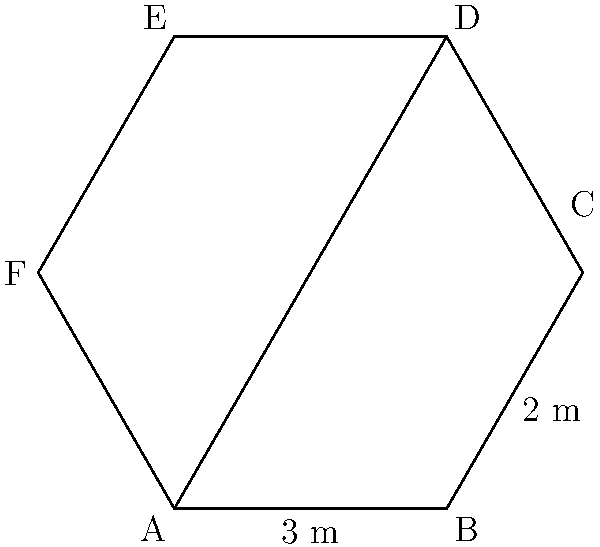A new coffee shop in your chain features a hexagonal coffee bar counter. Two sides of the hexagon measure 3 meters and 2 meters, as shown in the diagram. If all opposite sides of the hexagon are parallel and equal in length, calculate the perimeter of the coffee bar counter. To find the perimeter of the hexagonal coffee bar counter, we need to follow these steps:

1) In a hexagon with parallel opposite sides, there are three pairs of equal sides.

2) We are given two side lengths:
   - One side is 3 meters
   - An adjacent side is 2 meters

3) The opposite sides to these will have the same lengths:
   - The side opposite to the 3-meter side is also 3 meters
   - The side opposite to the 2-meter side is also 2 meters

4) We can deduce that the remaining two sides (which are opposite to each other) must also be equal. Let's call this length $x$ meters.

5) To find the perimeter, we sum up all side lengths:
   $\text{Perimeter} = 3 + 2 + x + 3 + 2 + x = 10 + 2x$ meters

6) To find $x$, we can use the property that opposite sides are parallel and equal. This means that the hexagon can be divided into two trapezoids by the diagonal AD.

7) In an equilateral trapezoid, the legs (non-parallel sides) are equal. So, $x = 2$ meters.

8) Substituting this back into our perimeter equation:
   $\text{Perimeter} = 10 + 2(2) = 10 + 4 = 14$ meters

Therefore, the perimeter of the hexagonal coffee bar counter is 14 meters.
Answer: 14 meters 